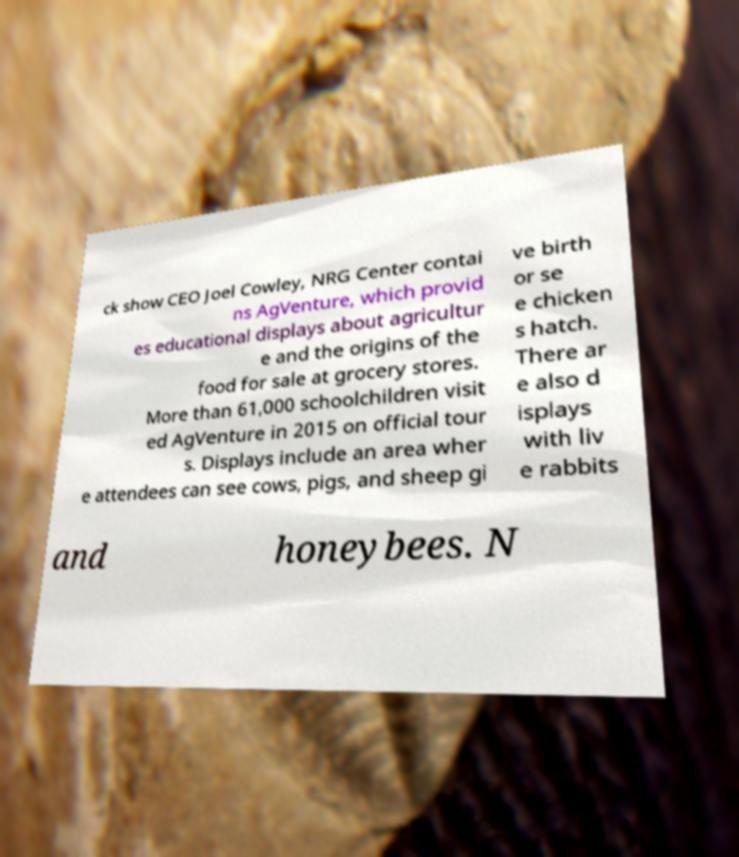Please read and relay the text visible in this image. What does it say? ck show CEO Joel Cowley, NRG Center contai ns AgVenture, which provid es educational displays about agricultur e and the origins of the food for sale at grocery stores. More than 61,000 schoolchildren visit ed AgVenture in 2015 on official tour s. Displays include an area wher e attendees can see cows, pigs, and sheep gi ve birth or se e chicken s hatch. There ar e also d isplays with liv e rabbits and honeybees. N 